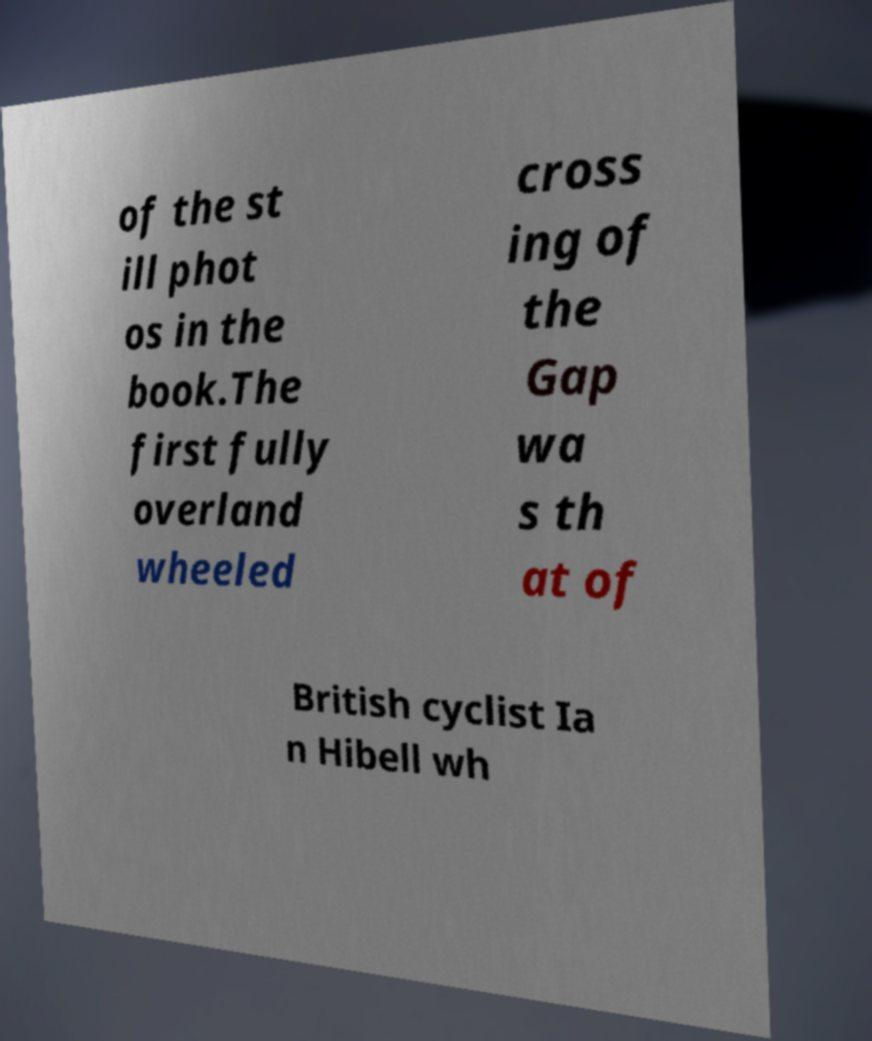There's text embedded in this image that I need extracted. Can you transcribe it verbatim? of the st ill phot os in the book.The first fully overland wheeled cross ing of the Gap wa s th at of British cyclist Ia n Hibell wh 